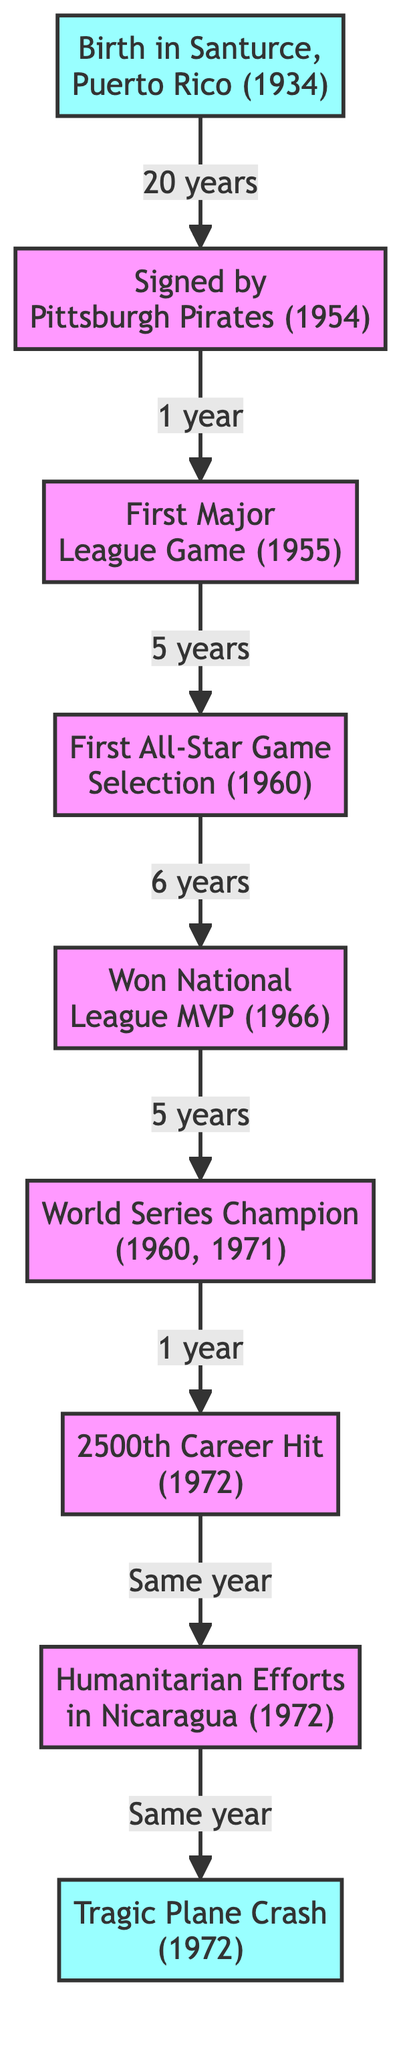What milestone marks the beginning of Roberto Clemente's journey? The journey starts with his birth in Santurce, Puerto Rico in 1934, denoted as the first node in the diagram.
Answer: Birth in Santurce, Puerto Rico (1934) How many nodes are in the diagram? The diagram consists of 9 nodes representing key milestones in Roberto Clemente's life and career.
Answer: 9 What was achieved in 1960 related to sports? The first World Series Championship for Roberto Clemente occurred in 1960, illustrated by an edge connecting nodes for the World Series Champion and the first All-Star Game Selection.
Answer: World Series Champion What event follows Roberto Clemente's 2500th career hit? Following the 2500th career hit in 1972, he engaged in humanitarian efforts in Nicaragua, as shown by an edge extending from the 2500th hit node to the humanitarian efforts node.
Answer: Humanitarian Efforts in Nicaragua (1972) What is the relationship between Roberto Clemente's National League MVP and his World Series Championships? The National League MVP won in 1966 leads to the two World Series Championships in 1960 and 1971, indicating that they are achievements connected in his career timeline.
Answer: Won National League MVP (1966) and World Series Champion (1960, 1971) What major life event occurs the same year as his humanitarian efforts? Roberto Clemente's tragic plane crash in 1972 occurred in the same year as his humanitarian efforts in Nicaragua, represented by a direct connection in the flow of the diagram.
Answer: Tragic Plane Crash (1972) 